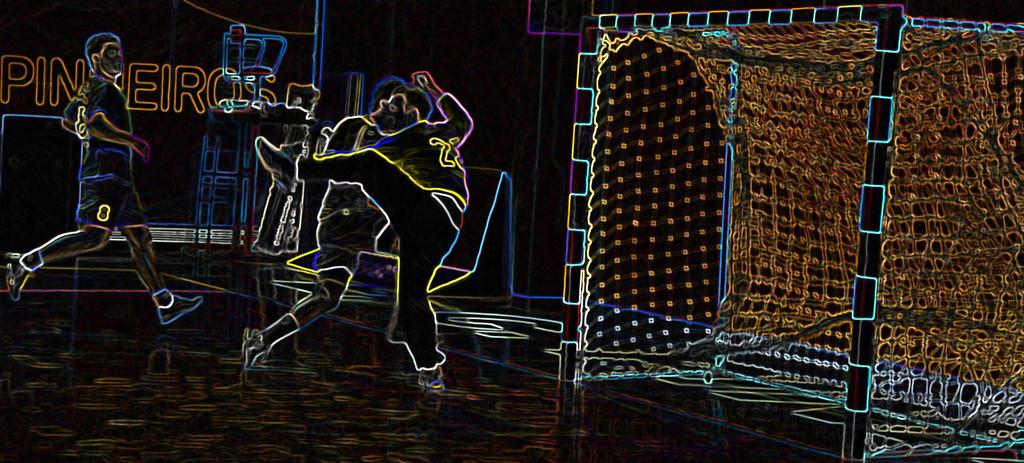What is the main subject of the image? The image is of a stage. Are there any decorations or features on the stage? Yes, there is a painting on the wall of the stage. What is the painting depicting? The painting depicts a football game concept. What type of wave can be seen in the painting on the stage? There is no wave present in the painting on the stage; it depicts a football game concept. What song is being played during the football game in the painting? There is no indication of any music or song being played in the painting, as it focuses on the football game concept. 